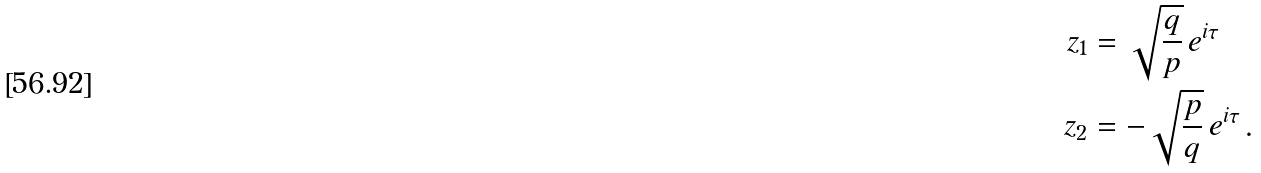Convert formula to latex. <formula><loc_0><loc_0><loc_500><loc_500>z _ { 1 } & = \sqrt { \frac { q } { p } } \, e ^ { i \tau } \\ z _ { 2 } & = - \sqrt { \frac { p } { q } } \, e ^ { i \tau } \, .</formula> 